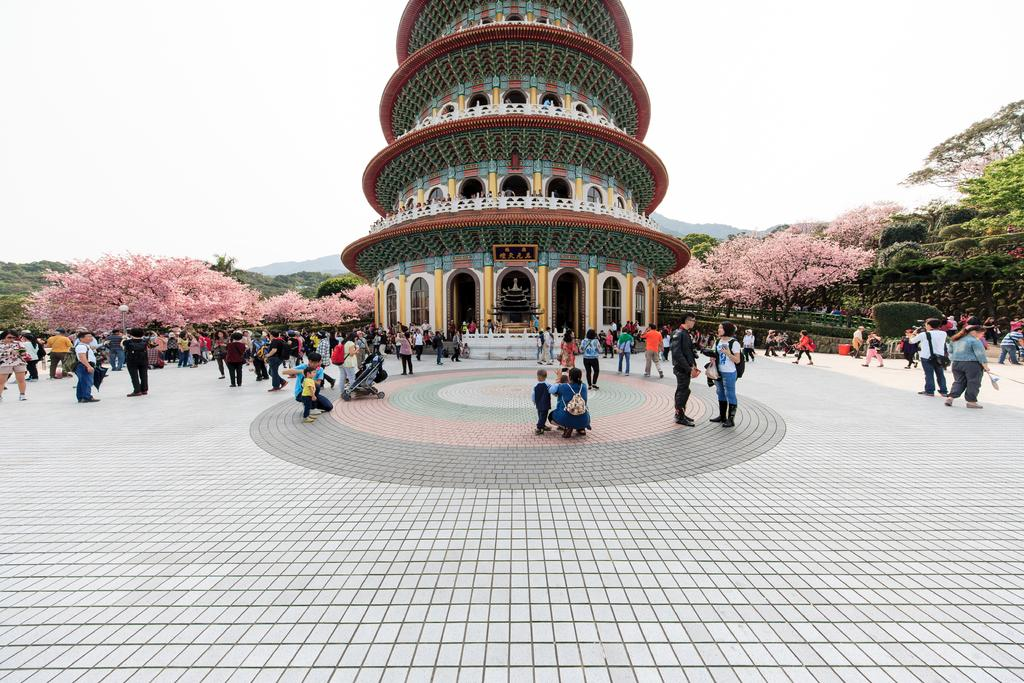How many people are in the image? There is a group of people present in the image. What are the people in the image doing? Some people are standing, while others are in a squat position. What can be seen in the background of the image? There is a building, trees, and the sky visible in the background of the image. Can you see any cobwebs in the image? There are no cobwebs present in the image. Is there a beggar visible in the image? There is no beggar present in the image. 